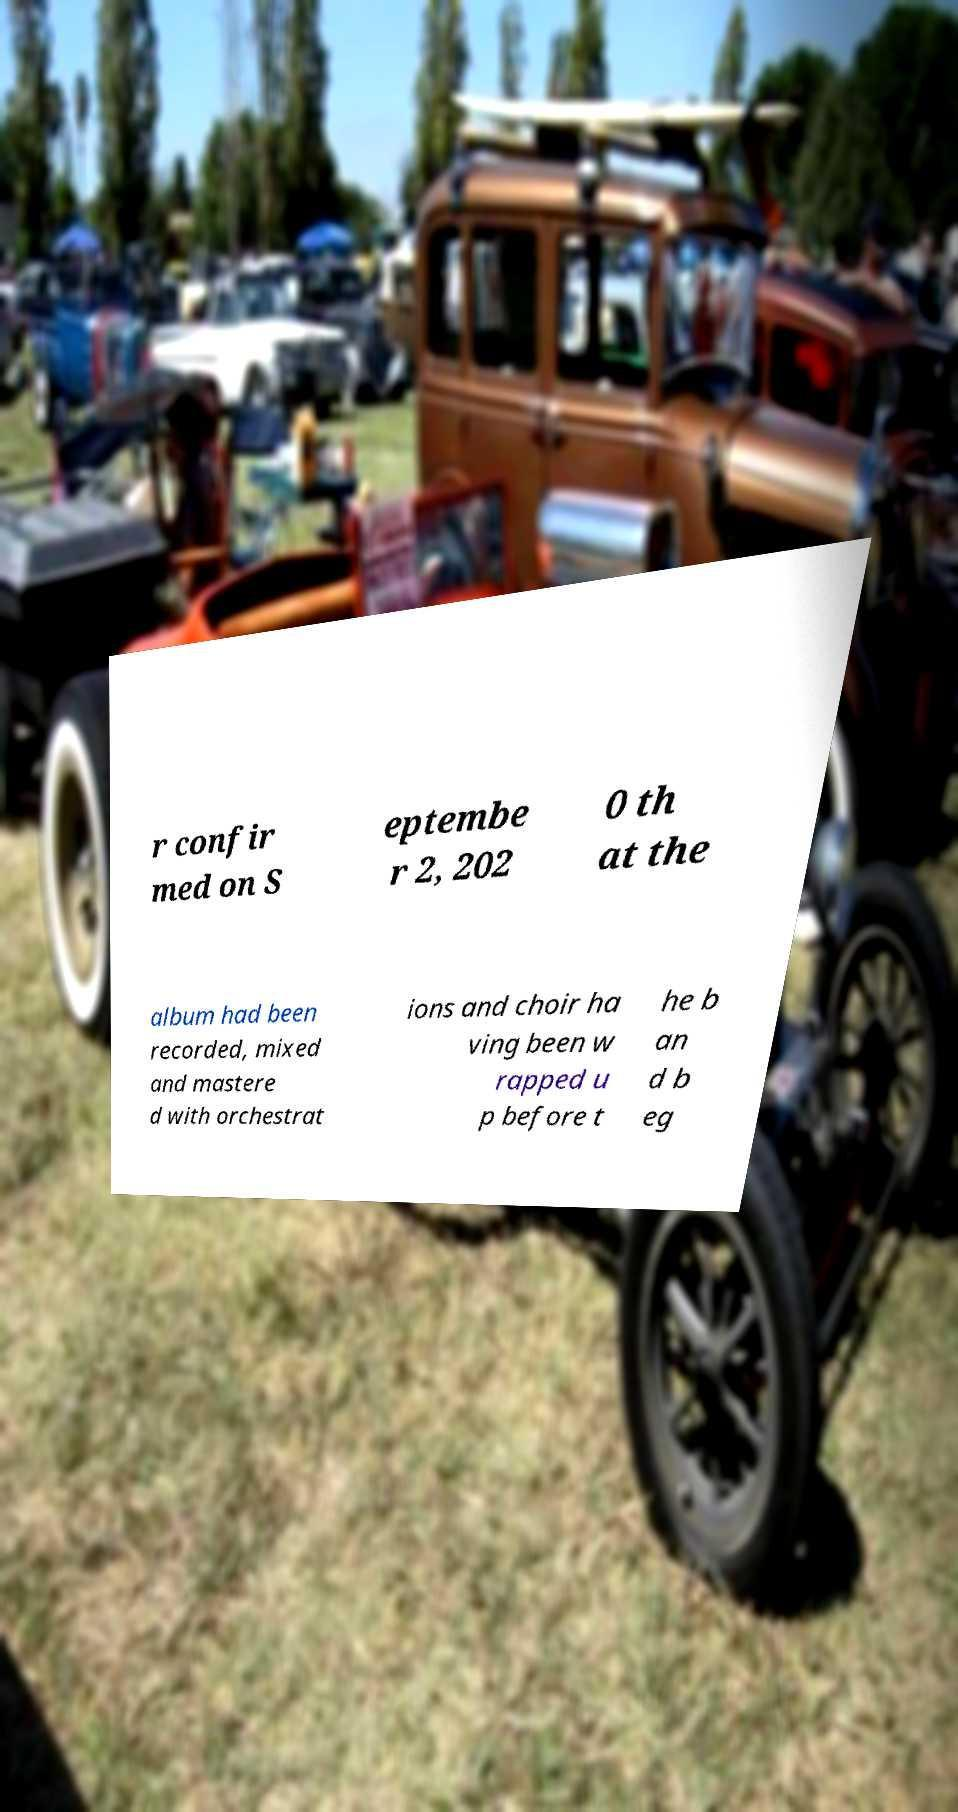Could you assist in decoding the text presented in this image and type it out clearly? r confir med on S eptembe r 2, 202 0 th at the album had been recorded, mixed and mastere d with orchestrat ions and choir ha ving been w rapped u p before t he b an d b eg 